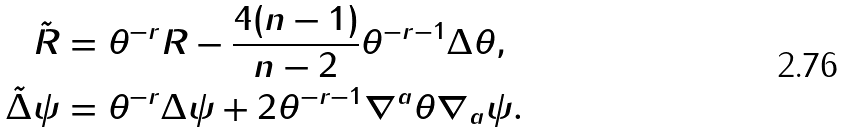Convert formula to latex. <formula><loc_0><loc_0><loc_500><loc_500>\tilde { R } & = \theta ^ { - r } R - \frac { 4 ( n - 1 ) } { n - 2 } \theta ^ { - r - 1 } \Delta \theta , \\ \tilde { \Delta } \psi & = \theta ^ { - r } \Delta \psi + 2 \theta ^ { - r - 1 } \nabla ^ { a } \theta \nabla _ { a } \psi . \\</formula> 